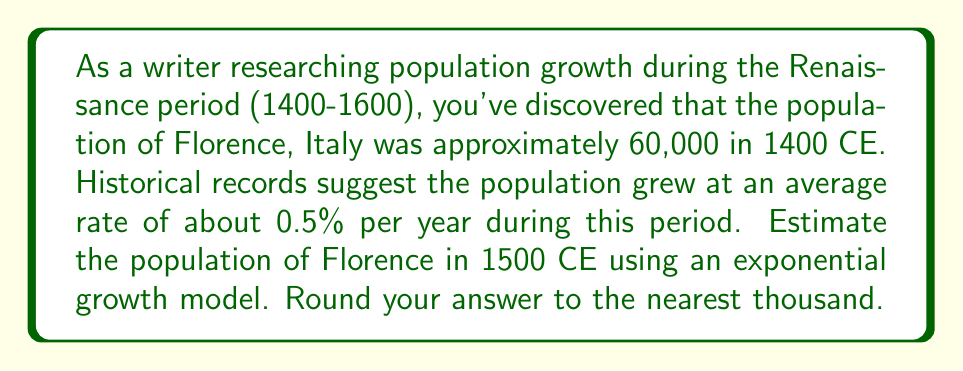Can you solve this math problem? To solve this problem, we'll use the exponential growth formula:

$$A = P(1 + r)^t$$

Where:
$A$ = Final amount (population in 1500 CE)
$P$ = Initial amount (population in 1400 CE)
$r$ = Growth rate (as a decimal)
$t$ = Time period (in years)

Given:
$P = 60,000$
$r = 0.005$ (0.5% expressed as a decimal)
$t = 100$ years

Let's substitute these values into the formula:

$$A = 60,000(1 + 0.005)^{100}$$

Now, let's calculate step by step:

1) First, calculate $(1 + 0.005)^{100}$:
   $$(1.005)^{100} \approx 1.6467$$

2) Multiply this by the initial population:
   $$60,000 \times 1.6467 \approx 98,802$$

3) Rounding to the nearest thousand:
   $$98,802 \approx 99,000$$

Therefore, the estimated population of Florence in 1500 CE is approximately 99,000.
Answer: 99,000 